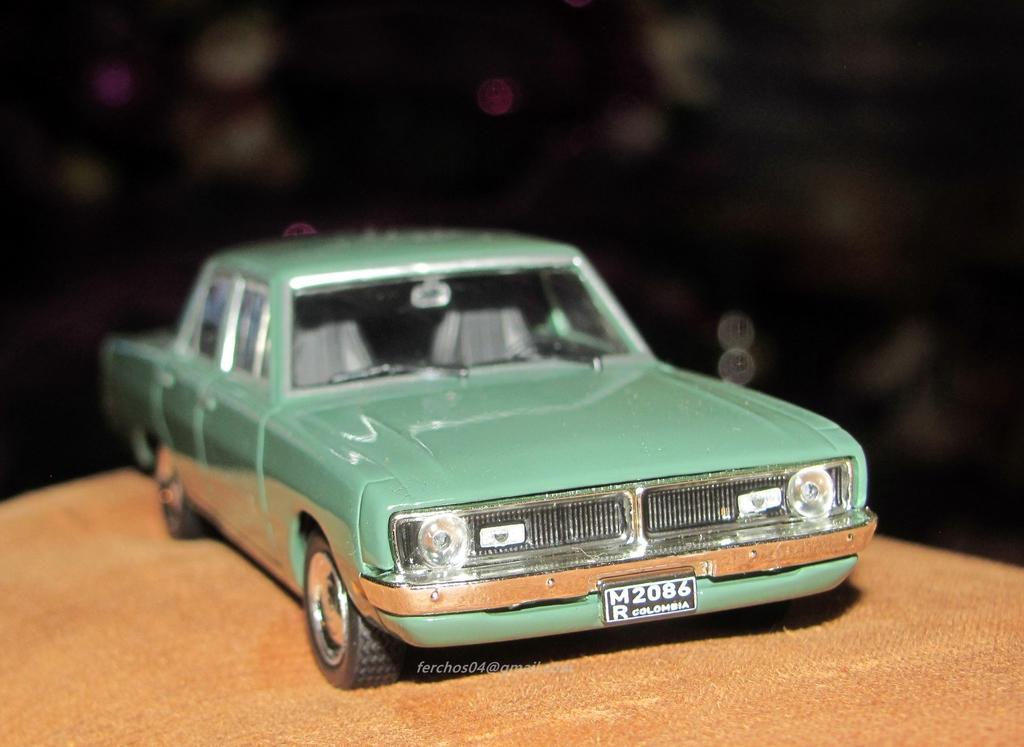Can you describe this image briefly? In this picture I can see a car toy placed on the cloth. 